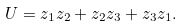Convert formula to latex. <formula><loc_0><loc_0><loc_500><loc_500>U = z _ { 1 } z _ { 2 } + z _ { 2 } z _ { 3 } + z _ { 3 } z _ { 1 } .</formula> 